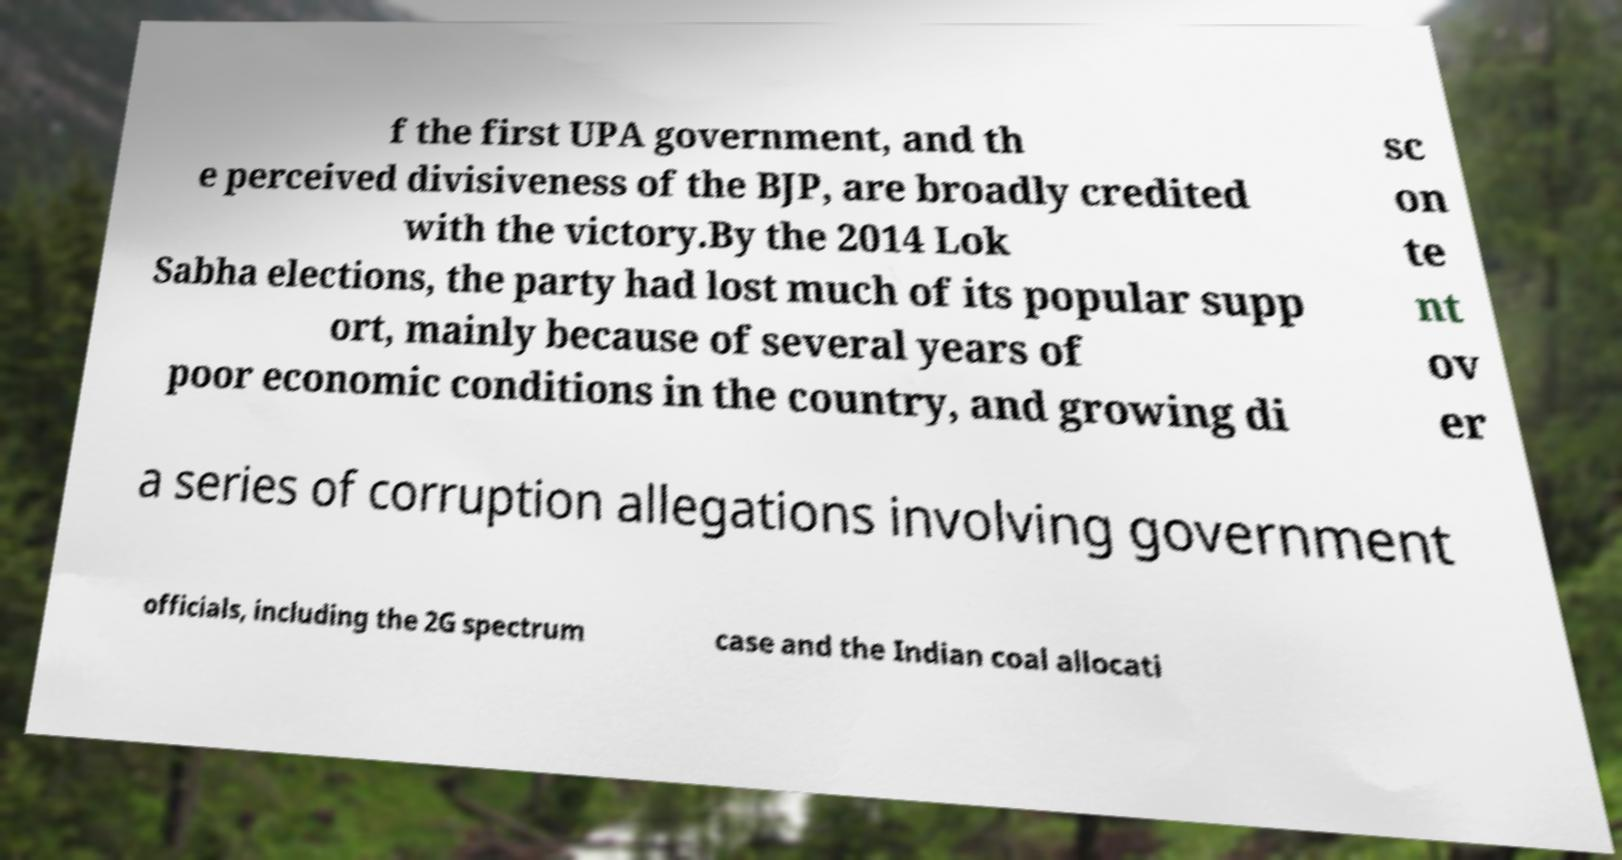What messages or text are displayed in this image? I need them in a readable, typed format. f the first UPA government, and th e perceived divisiveness of the BJP, are broadly credited with the victory.By the 2014 Lok Sabha elections, the party had lost much of its popular supp ort, mainly because of several years of poor economic conditions in the country, and growing di sc on te nt ov er a series of corruption allegations involving government officials, including the 2G spectrum case and the Indian coal allocati 